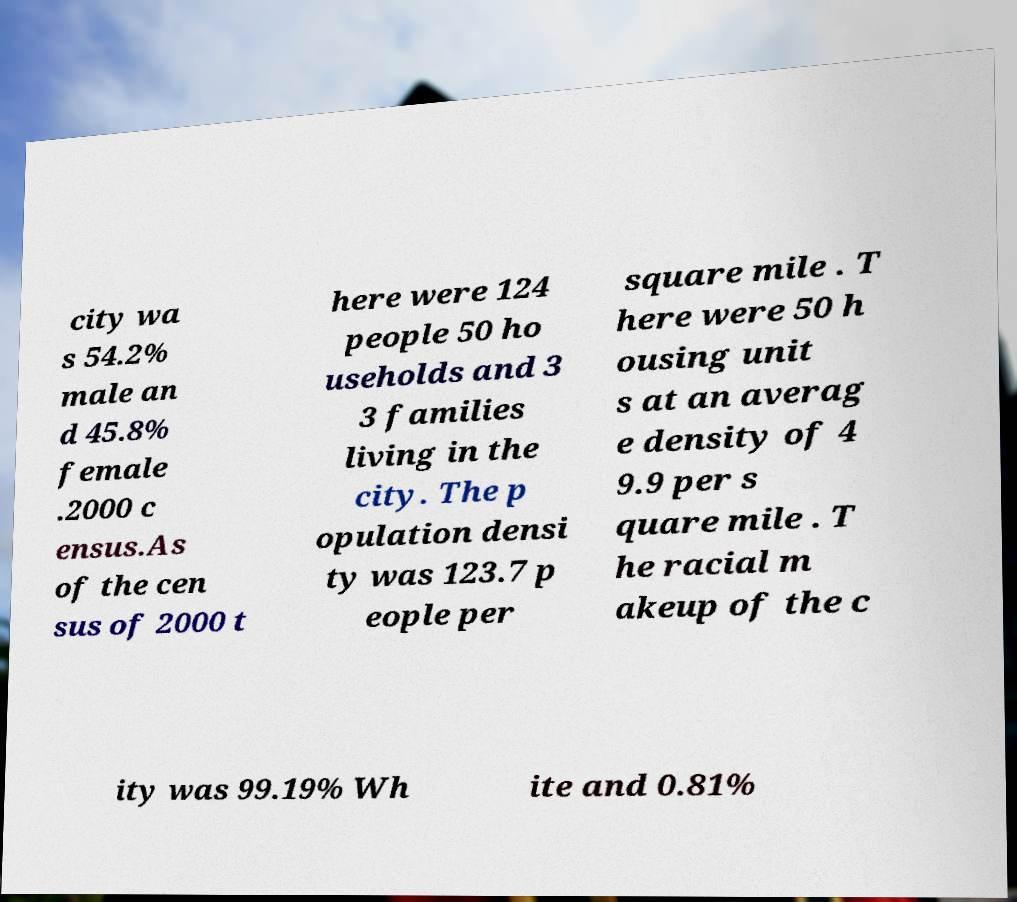Can you accurately transcribe the text from the provided image for me? city wa s 54.2% male an d 45.8% female .2000 c ensus.As of the cen sus of 2000 t here were 124 people 50 ho useholds and 3 3 families living in the city. The p opulation densi ty was 123.7 p eople per square mile . T here were 50 h ousing unit s at an averag e density of 4 9.9 per s quare mile . T he racial m akeup of the c ity was 99.19% Wh ite and 0.81% 